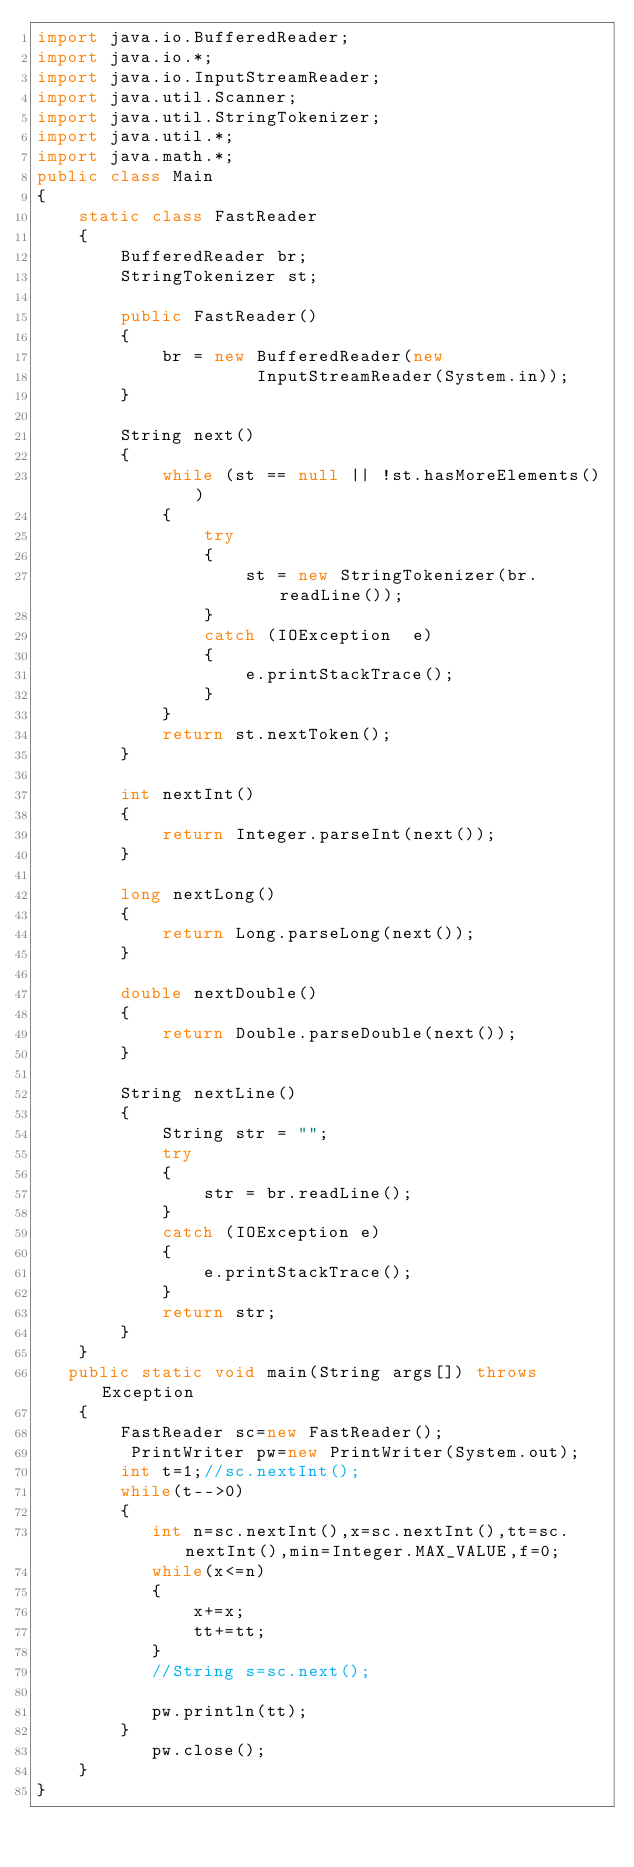Convert code to text. <code><loc_0><loc_0><loc_500><loc_500><_Java_>import java.io.BufferedReader; 
import java.io.*;
import java.io.InputStreamReader; 
import java.util.Scanner; 
import java.util.StringTokenizer; 
import java.util.*;
import java.math.*;
public class Main 
{ 
    static class FastReader 
    { 
        BufferedReader br; 
        StringTokenizer st; 
  
        public FastReader()
        { 
            br = new BufferedReader(new
                     InputStreamReader(System.in)); 
        } 
  
        String next()
        { 
            while (st == null || !st.hasMoreElements()) 
            { 
                try
                { 
                    st = new StringTokenizer(br.readLine()); 
                } 
                catch (IOException  e) 
                { 
                    e.printStackTrace(); 
                } 
            } 
            return st.nextToken(); 
        } 
  
        int nextInt() 
        { 
            return Integer.parseInt(next()); 
        } 
  
        long nextLong() 
        { 
            return Long.parseLong(next()); 
        } 
  
        double nextDouble() 
        { 
            return Double.parseDouble(next()); 
        } 
  
        String nextLine() 
        { 
            String str = ""; 
            try
            { 
                str = br.readLine();
            } 
            catch (IOException e) 
            { 
                e.printStackTrace(); 
            } 
            return str; 
        } 
    } 
   public static void main(String args[]) throws Exception
    {
        FastReader sc=new FastReader();
         PrintWriter pw=new PrintWriter(System.out);
        int t=1;//sc.nextInt();
        while(t-->0)
        {
           int n=sc.nextInt(),x=sc.nextInt(),tt=sc.nextInt(),min=Integer.MAX_VALUE,f=0;
           while(x<=n)
           {
               x+=x;
               tt+=tt;
           }
           //String s=sc.next();

           pw.println(tt);
        }
           pw.close();
    }
}
  </code> 